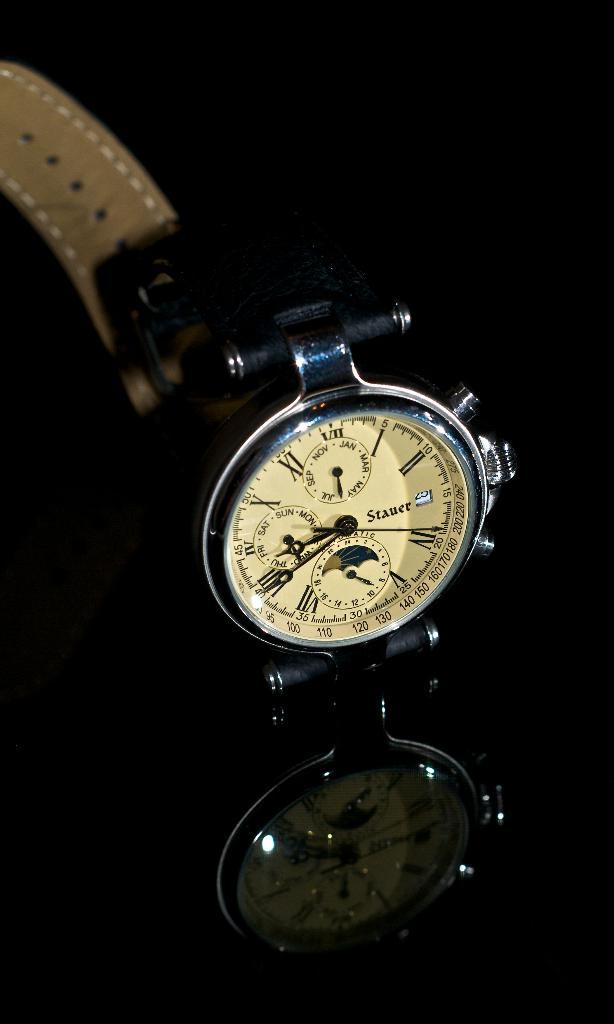What roman numeral is the seconds hand pointing at?
Provide a succinct answer. Iv. What time is it?
Provide a succinct answer. 8:40. 